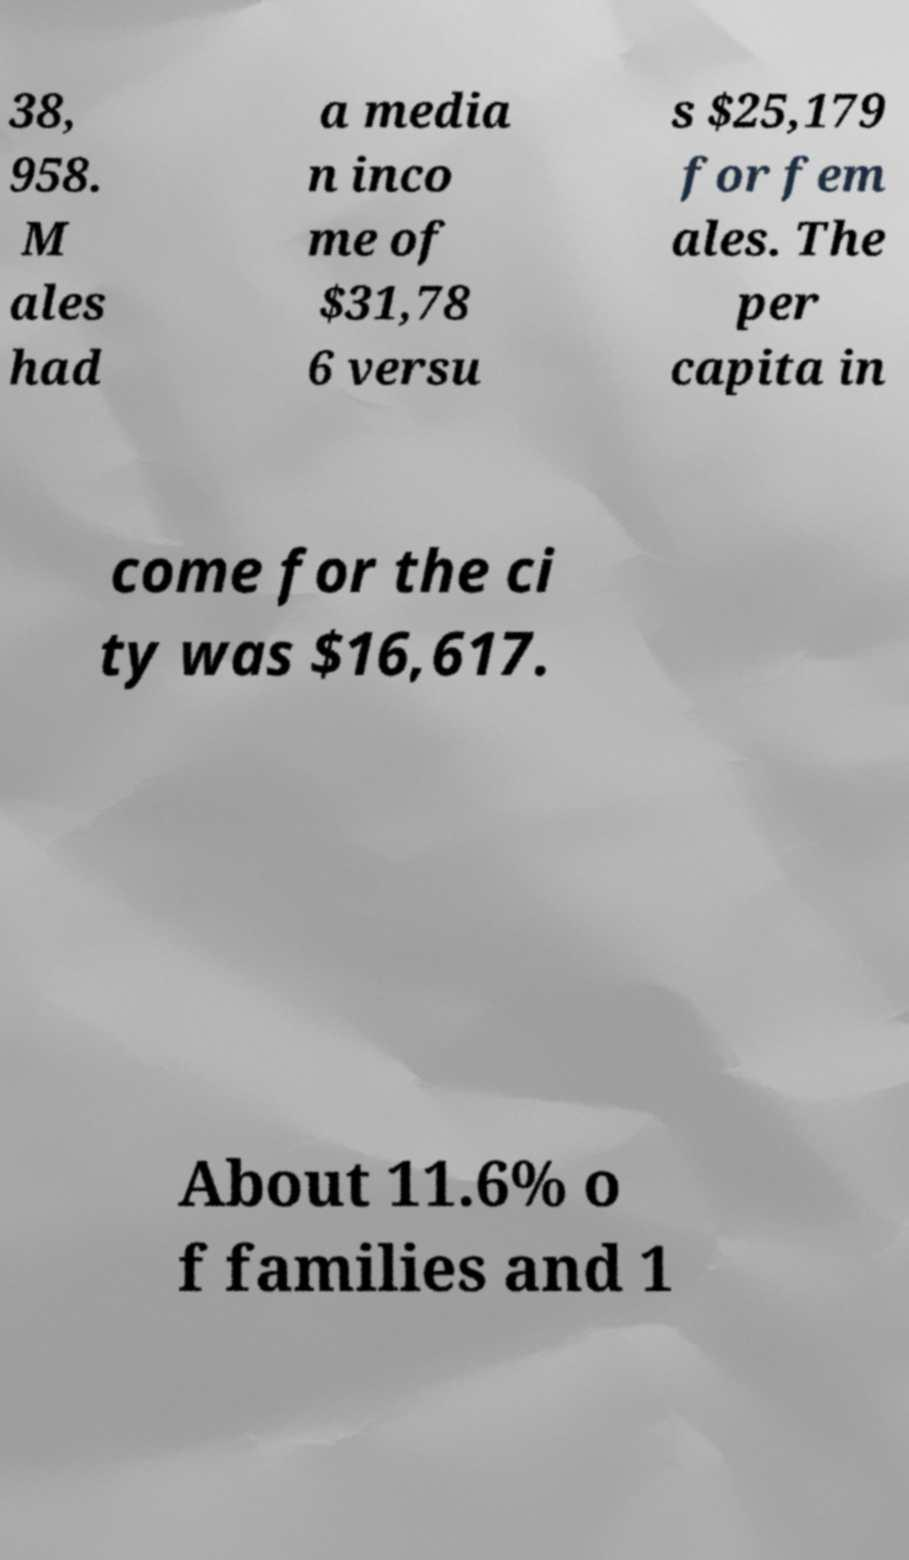Could you extract and type out the text from this image? 38, 958. M ales had a media n inco me of $31,78 6 versu s $25,179 for fem ales. The per capita in come for the ci ty was $16,617. About 11.6% o f families and 1 